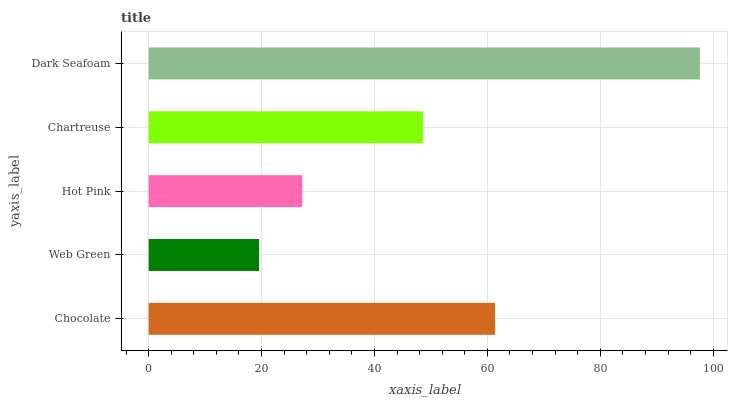Is Web Green the minimum?
Answer yes or no. Yes. Is Dark Seafoam the maximum?
Answer yes or no. Yes. Is Hot Pink the minimum?
Answer yes or no. No. Is Hot Pink the maximum?
Answer yes or no. No. Is Hot Pink greater than Web Green?
Answer yes or no. Yes. Is Web Green less than Hot Pink?
Answer yes or no. Yes. Is Web Green greater than Hot Pink?
Answer yes or no. No. Is Hot Pink less than Web Green?
Answer yes or no. No. Is Chartreuse the high median?
Answer yes or no. Yes. Is Chartreuse the low median?
Answer yes or no. Yes. Is Chocolate the high median?
Answer yes or no. No. Is Hot Pink the low median?
Answer yes or no. No. 